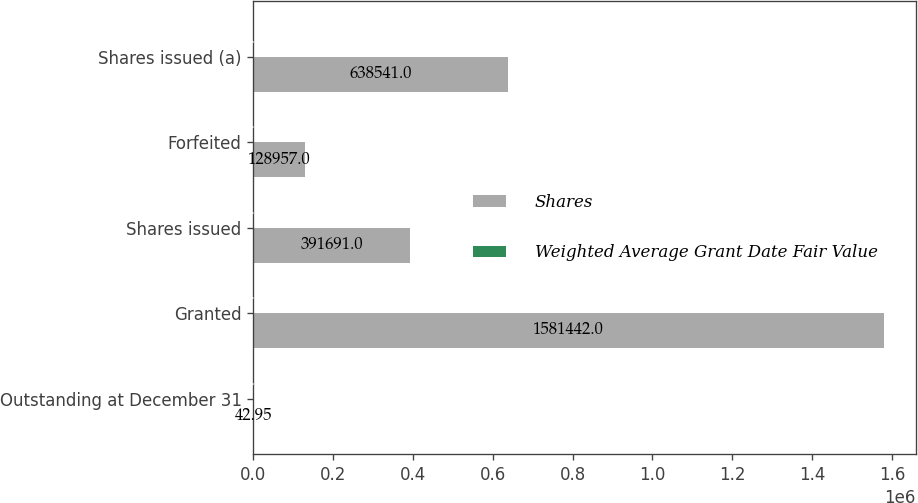Convert chart. <chart><loc_0><loc_0><loc_500><loc_500><stacked_bar_chart><ecel><fcel>Outstanding at December 31<fcel>Granted<fcel>Shares issued<fcel>Forfeited<fcel>Shares issued (a)<nl><fcel>Shares<fcel>42.95<fcel>1.58144e+06<fcel>391691<fcel>128957<fcel>638541<nl><fcel>Weighted Average Grant Date Fair Value<fcel>38.61<fcel>42.95<fcel>40.88<fcel>41.01<fcel>37.78<nl></chart> 